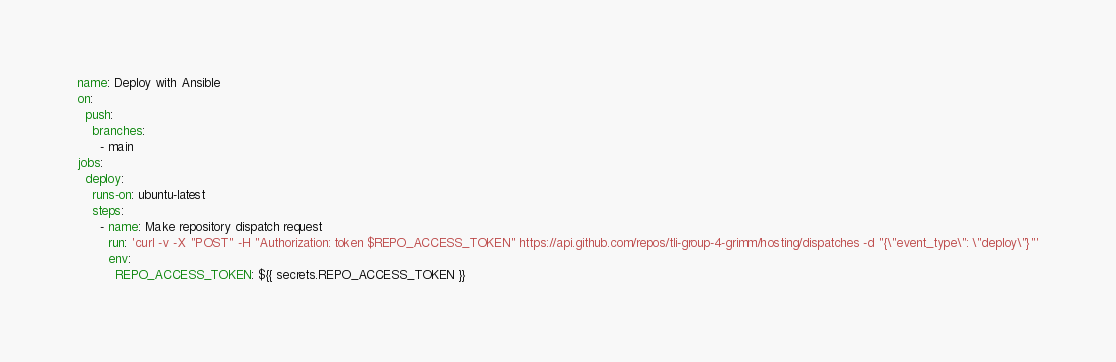Convert code to text. <code><loc_0><loc_0><loc_500><loc_500><_YAML_>name: Deploy with Ansible
on:
  push:
    branches:
      - main
jobs:
  deploy:
    runs-on: ubuntu-latest
    steps:
      - name: Make repository dispatch request
        run: 'curl -v -X "POST" -H "Authorization: token $REPO_ACCESS_TOKEN" https://api.github.com/repos/tli-group-4-grimm/hosting/dispatches -d "{\"event_type\": \"deploy\"}"'
        env:
          REPO_ACCESS_TOKEN: ${{ secrets.REPO_ACCESS_TOKEN }}
</code> 